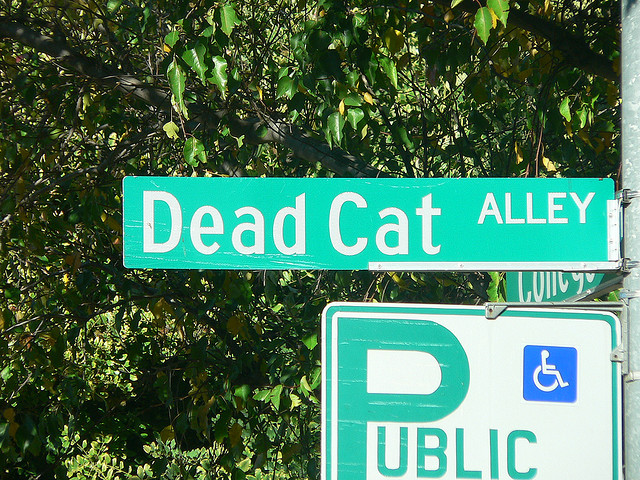<image>What city are these streets in? It is ambiguous what city these streets are in. It could be any city. What city are these streets in? I don't know what city these streets are in. It can be any city. 